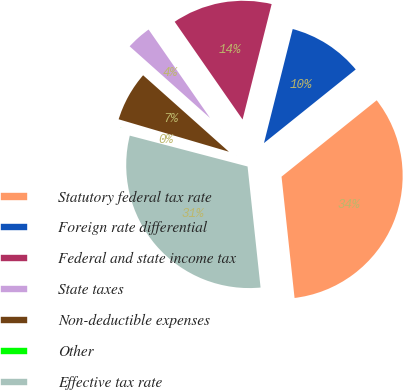<chart> <loc_0><loc_0><loc_500><loc_500><pie_chart><fcel>Statutory federal tax rate<fcel>Foreign rate differential<fcel>Federal and state income tax<fcel>State taxes<fcel>Non-deductible expenses<fcel>Other<fcel>Effective tax rate<nl><fcel>34.06%<fcel>10.31%<fcel>13.59%<fcel>3.75%<fcel>7.03%<fcel>0.48%<fcel>30.78%<nl></chart> 